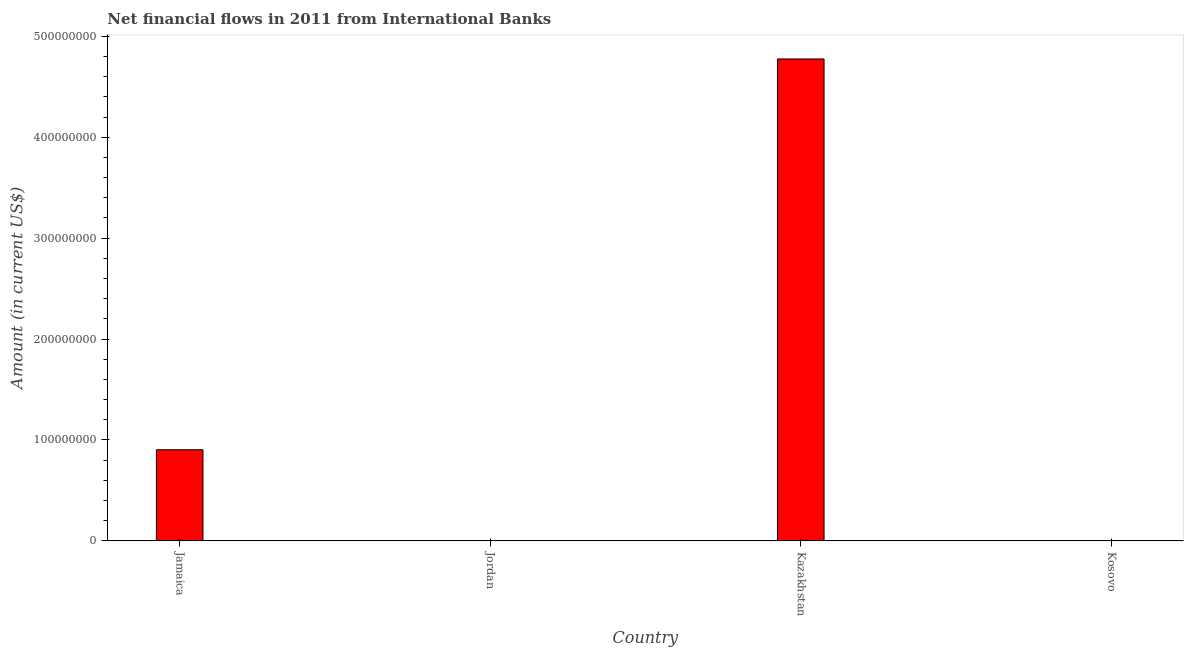What is the title of the graph?
Give a very brief answer. Net financial flows in 2011 from International Banks. What is the net financial flows from ibrd in Kazakhstan?
Ensure brevity in your answer.  4.78e+08. Across all countries, what is the maximum net financial flows from ibrd?
Offer a terse response. 4.78e+08. In which country was the net financial flows from ibrd maximum?
Your answer should be very brief. Kazakhstan. What is the sum of the net financial flows from ibrd?
Provide a succinct answer. 5.68e+08. What is the difference between the net financial flows from ibrd in Jamaica and Kazakhstan?
Provide a succinct answer. -3.87e+08. What is the average net financial flows from ibrd per country?
Provide a short and direct response. 1.42e+08. What is the median net financial flows from ibrd?
Provide a succinct answer. 4.51e+07. What is the ratio of the net financial flows from ibrd in Jamaica to that in Kazakhstan?
Ensure brevity in your answer.  0.19. What is the difference between the highest and the lowest net financial flows from ibrd?
Give a very brief answer. 4.78e+08. Are all the bars in the graph horizontal?
Keep it short and to the point. No. Are the values on the major ticks of Y-axis written in scientific E-notation?
Keep it short and to the point. No. What is the Amount (in current US$) of Jamaica?
Make the answer very short. 9.02e+07. What is the Amount (in current US$) in Jordan?
Your answer should be very brief. 0. What is the Amount (in current US$) of Kazakhstan?
Offer a very short reply. 4.78e+08. What is the Amount (in current US$) in Kosovo?
Make the answer very short. 0. What is the difference between the Amount (in current US$) in Jamaica and Kazakhstan?
Your answer should be compact. -3.87e+08. What is the ratio of the Amount (in current US$) in Jamaica to that in Kazakhstan?
Keep it short and to the point. 0.19. 